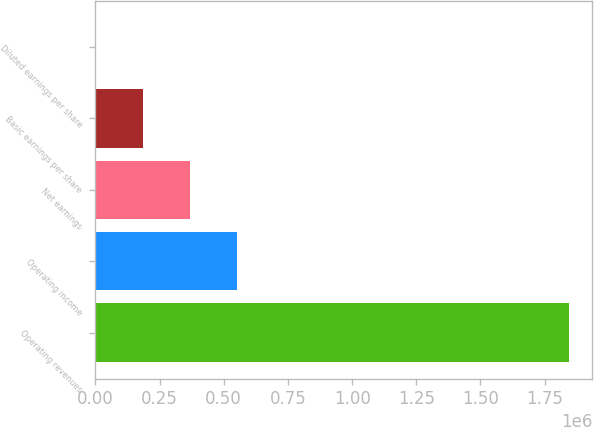Convert chart to OTSL. <chart><loc_0><loc_0><loc_500><loc_500><bar_chart><fcel>Operating revenues<fcel>Operating income<fcel>Net earnings<fcel>Basic earnings per share<fcel>Diluted earnings per share<nl><fcel>1.84333e+06<fcel>553001<fcel>368668<fcel>184334<fcel>0.91<nl></chart> 